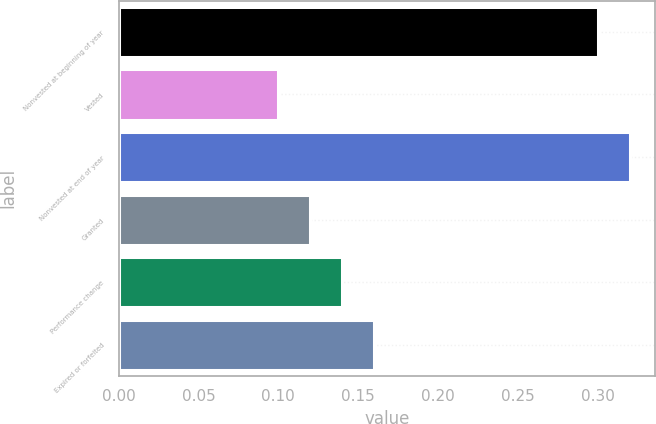Convert chart. <chart><loc_0><loc_0><loc_500><loc_500><bar_chart><fcel>Nonvested at beginning of year<fcel>Vested<fcel>Nonvested at end of year<fcel>Granted<fcel>Performance change<fcel>Expired or forfeited<nl><fcel>0.3<fcel>0.1<fcel>0.32<fcel>0.12<fcel>0.14<fcel>0.16<nl></chart> 